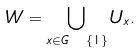<formula> <loc_0><loc_0><loc_500><loc_500>W = \bigcup _ { x \in G \ \{ 1 \} } U _ { x } .</formula> 